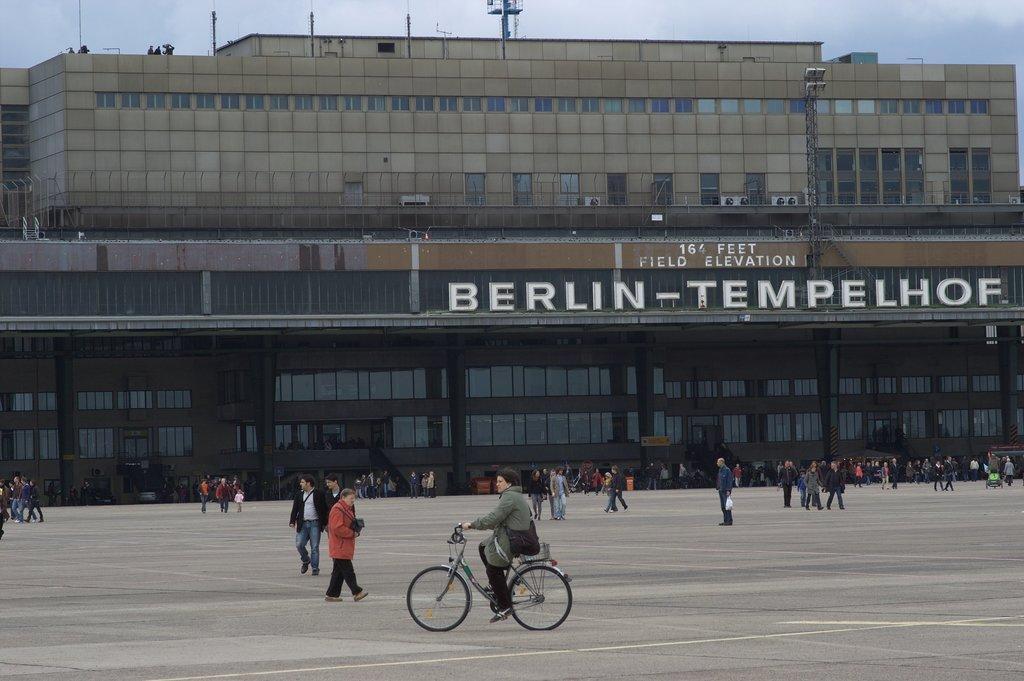How would you summarize this image in a sentence or two? In this picture there is a boy in the center of the image, he is cycling and there are other people at the bottom side of the image and there is a building in the center of the image, there are many windows on the building and there are towers at the top side of the image. 